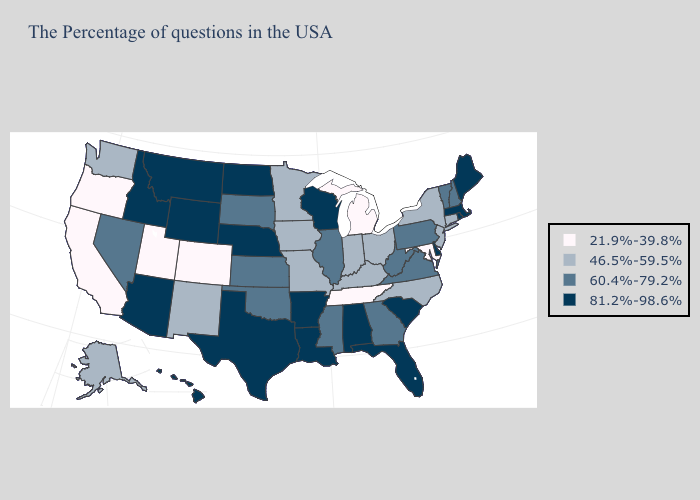Name the states that have a value in the range 81.2%-98.6%?
Give a very brief answer. Maine, Massachusetts, Rhode Island, Delaware, South Carolina, Florida, Alabama, Wisconsin, Louisiana, Arkansas, Nebraska, Texas, North Dakota, Wyoming, Montana, Arizona, Idaho, Hawaii. Does the first symbol in the legend represent the smallest category?
Be succinct. Yes. Name the states that have a value in the range 21.9%-39.8%?
Be succinct. Maryland, Michigan, Tennessee, Colorado, Utah, California, Oregon. Among the states that border Wisconsin , does Michigan have the highest value?
Short answer required. No. Name the states that have a value in the range 21.9%-39.8%?
Short answer required. Maryland, Michigan, Tennessee, Colorado, Utah, California, Oregon. Among the states that border New Mexico , which have the lowest value?
Quick response, please. Colorado, Utah. Does California have the lowest value in the USA?
Concise answer only. Yes. Name the states that have a value in the range 21.9%-39.8%?
Be succinct. Maryland, Michigan, Tennessee, Colorado, Utah, California, Oregon. Does Hawaii have a lower value than Texas?
Keep it brief. No. Does the map have missing data?
Be succinct. No. What is the highest value in the USA?
Write a very short answer. 81.2%-98.6%. What is the lowest value in the Northeast?
Write a very short answer. 46.5%-59.5%. Does Arkansas have a higher value than Ohio?
Write a very short answer. Yes. Is the legend a continuous bar?
Concise answer only. No. Among the states that border Wisconsin , does Minnesota have the highest value?
Short answer required. No. 